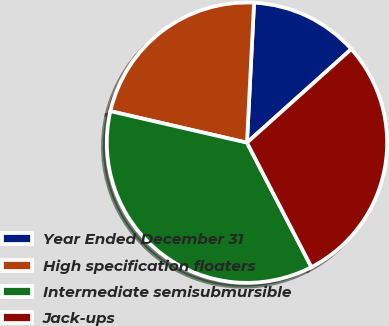Convert chart. <chart><loc_0><loc_0><loc_500><loc_500><pie_chart><fcel>Year Ended December 31<fcel>High specification floaters<fcel>Intermediate semisubmursible<fcel>Jack-ups<nl><fcel>12.56%<fcel>22.2%<fcel>36.22%<fcel>29.03%<nl></chart> 